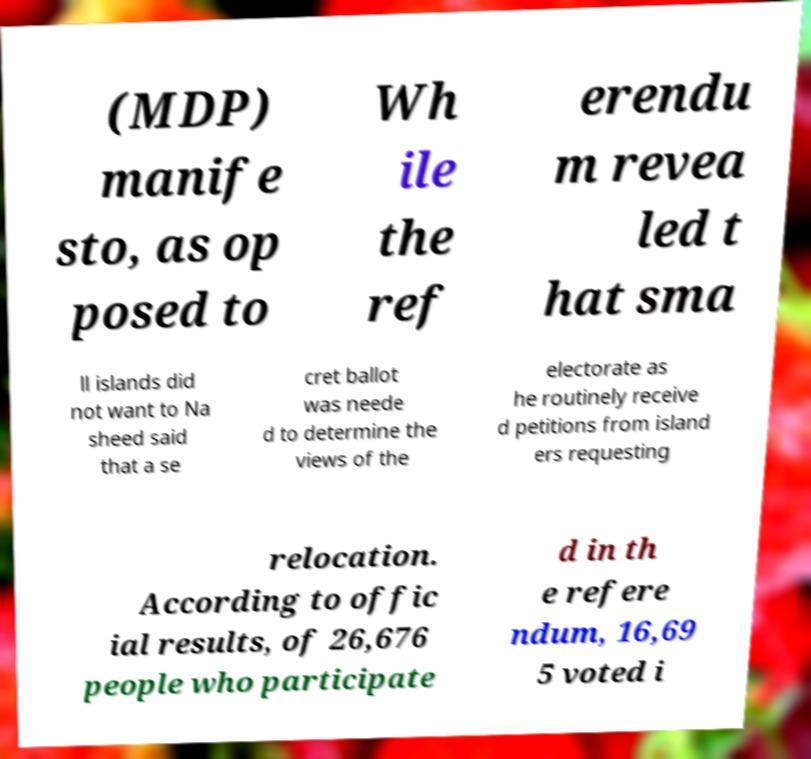Please identify and transcribe the text found in this image. (MDP) manife sto, as op posed to Wh ile the ref erendu m revea led t hat sma ll islands did not want to Na sheed said that a se cret ballot was neede d to determine the views of the electorate as he routinely receive d petitions from island ers requesting relocation. According to offic ial results, of 26,676 people who participate d in th e refere ndum, 16,69 5 voted i 